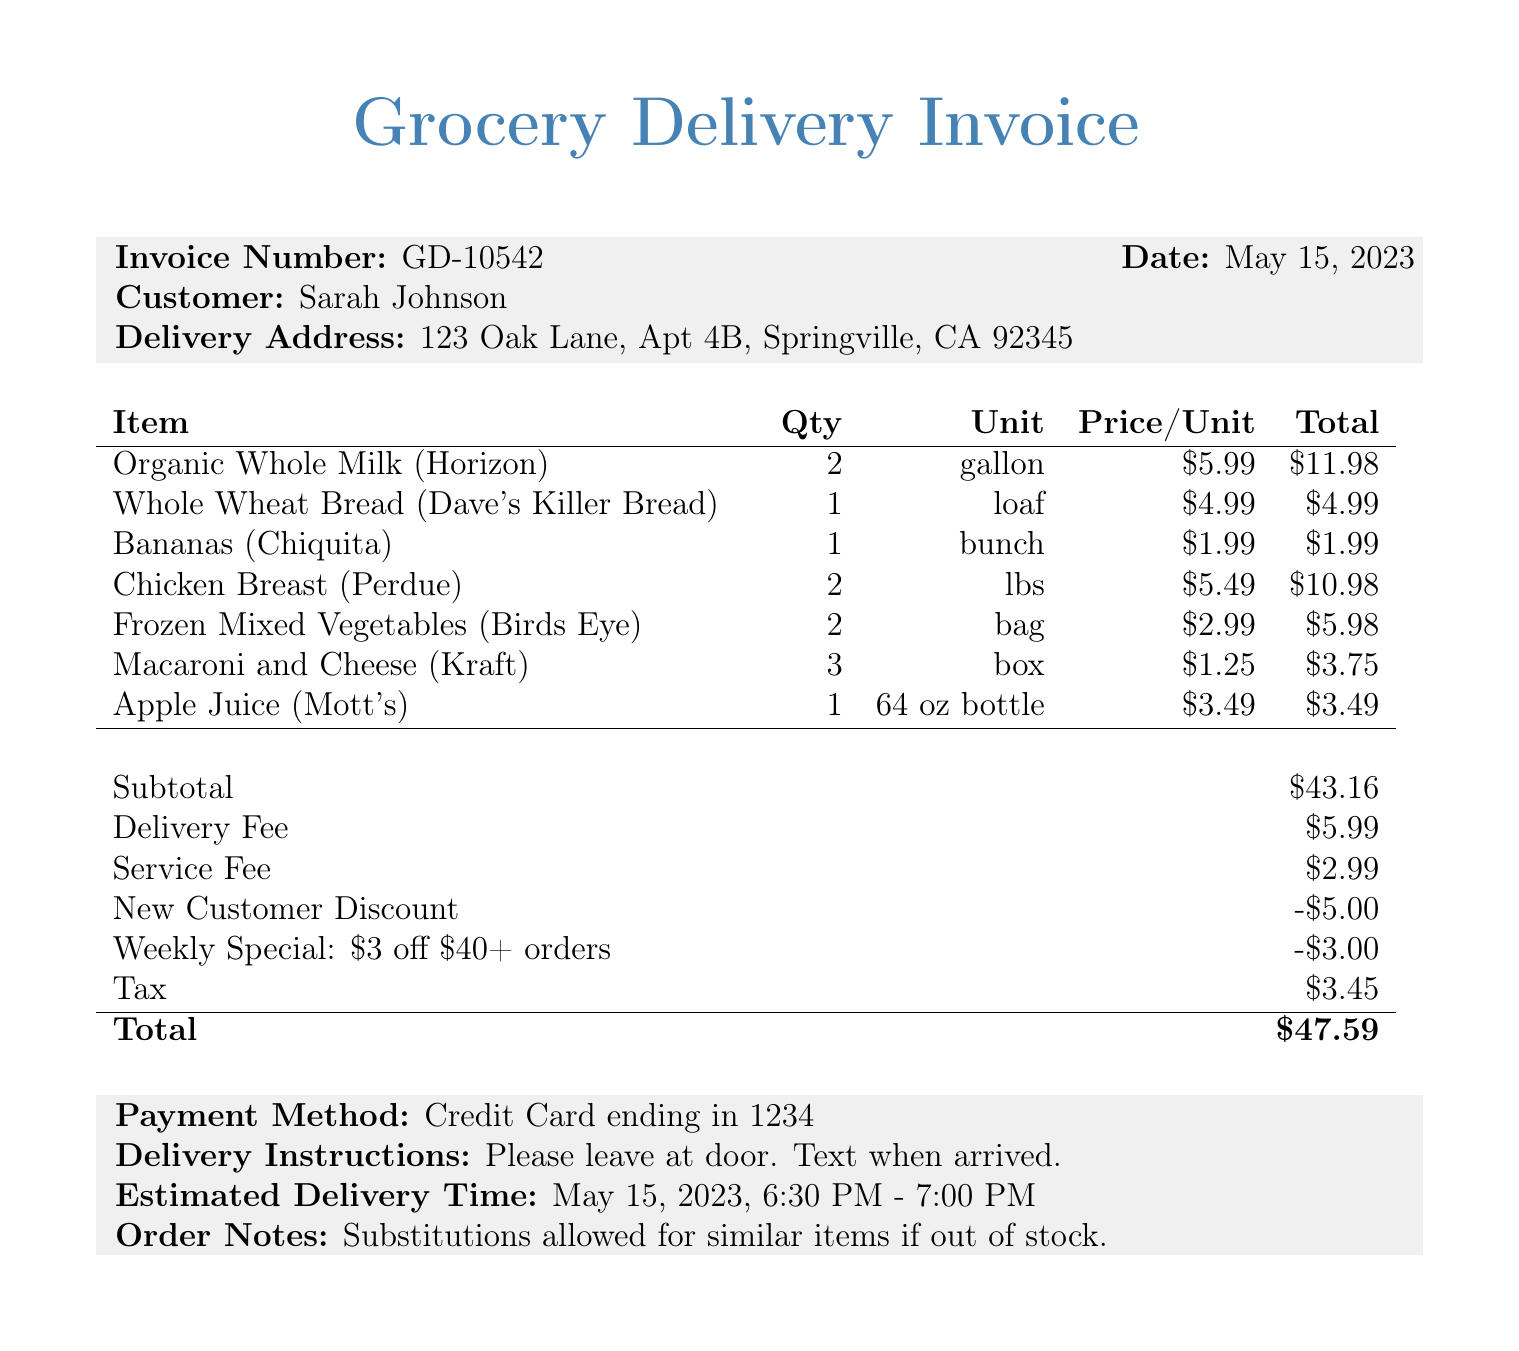what is the invoice number? The invoice number is listed clearly at the top of the invoice as a unique identifier.
Answer: GD-10542 what is the date of the invoice? The date is specified in the document to indicate when the invoice was generated.
Answer: May 15, 2023 who is the customer? The customer’s name is provided in the invoice for identification.
Answer: Sarah Johnson what is the subtotal amount? The subtotal amount includes the cost of all items before additional fees or discounts.
Answer: $43.16 how much is the delivery fee? The delivery fee is a separate charge that's added to the subtotal before discounts and tax.
Answer: $5.99 what type of discount is mentioned for new customers? The document specifies discounts available for new customers to encourage initial purchases.
Answer: New Customer Discount how much was the total discount amount? The total discounts combine various discounts applied to the invoice amount.
Answer: $8.00 what is the estimated delivery time? The estimated delivery time provides information about when the delivery is expected.
Answer: May 15, 2023, 6:30 PM - 7:00 PM what payment method was used? The payment method indicates how the customer paid for the groceries delivered.
Answer: Credit Card ending in 1234 